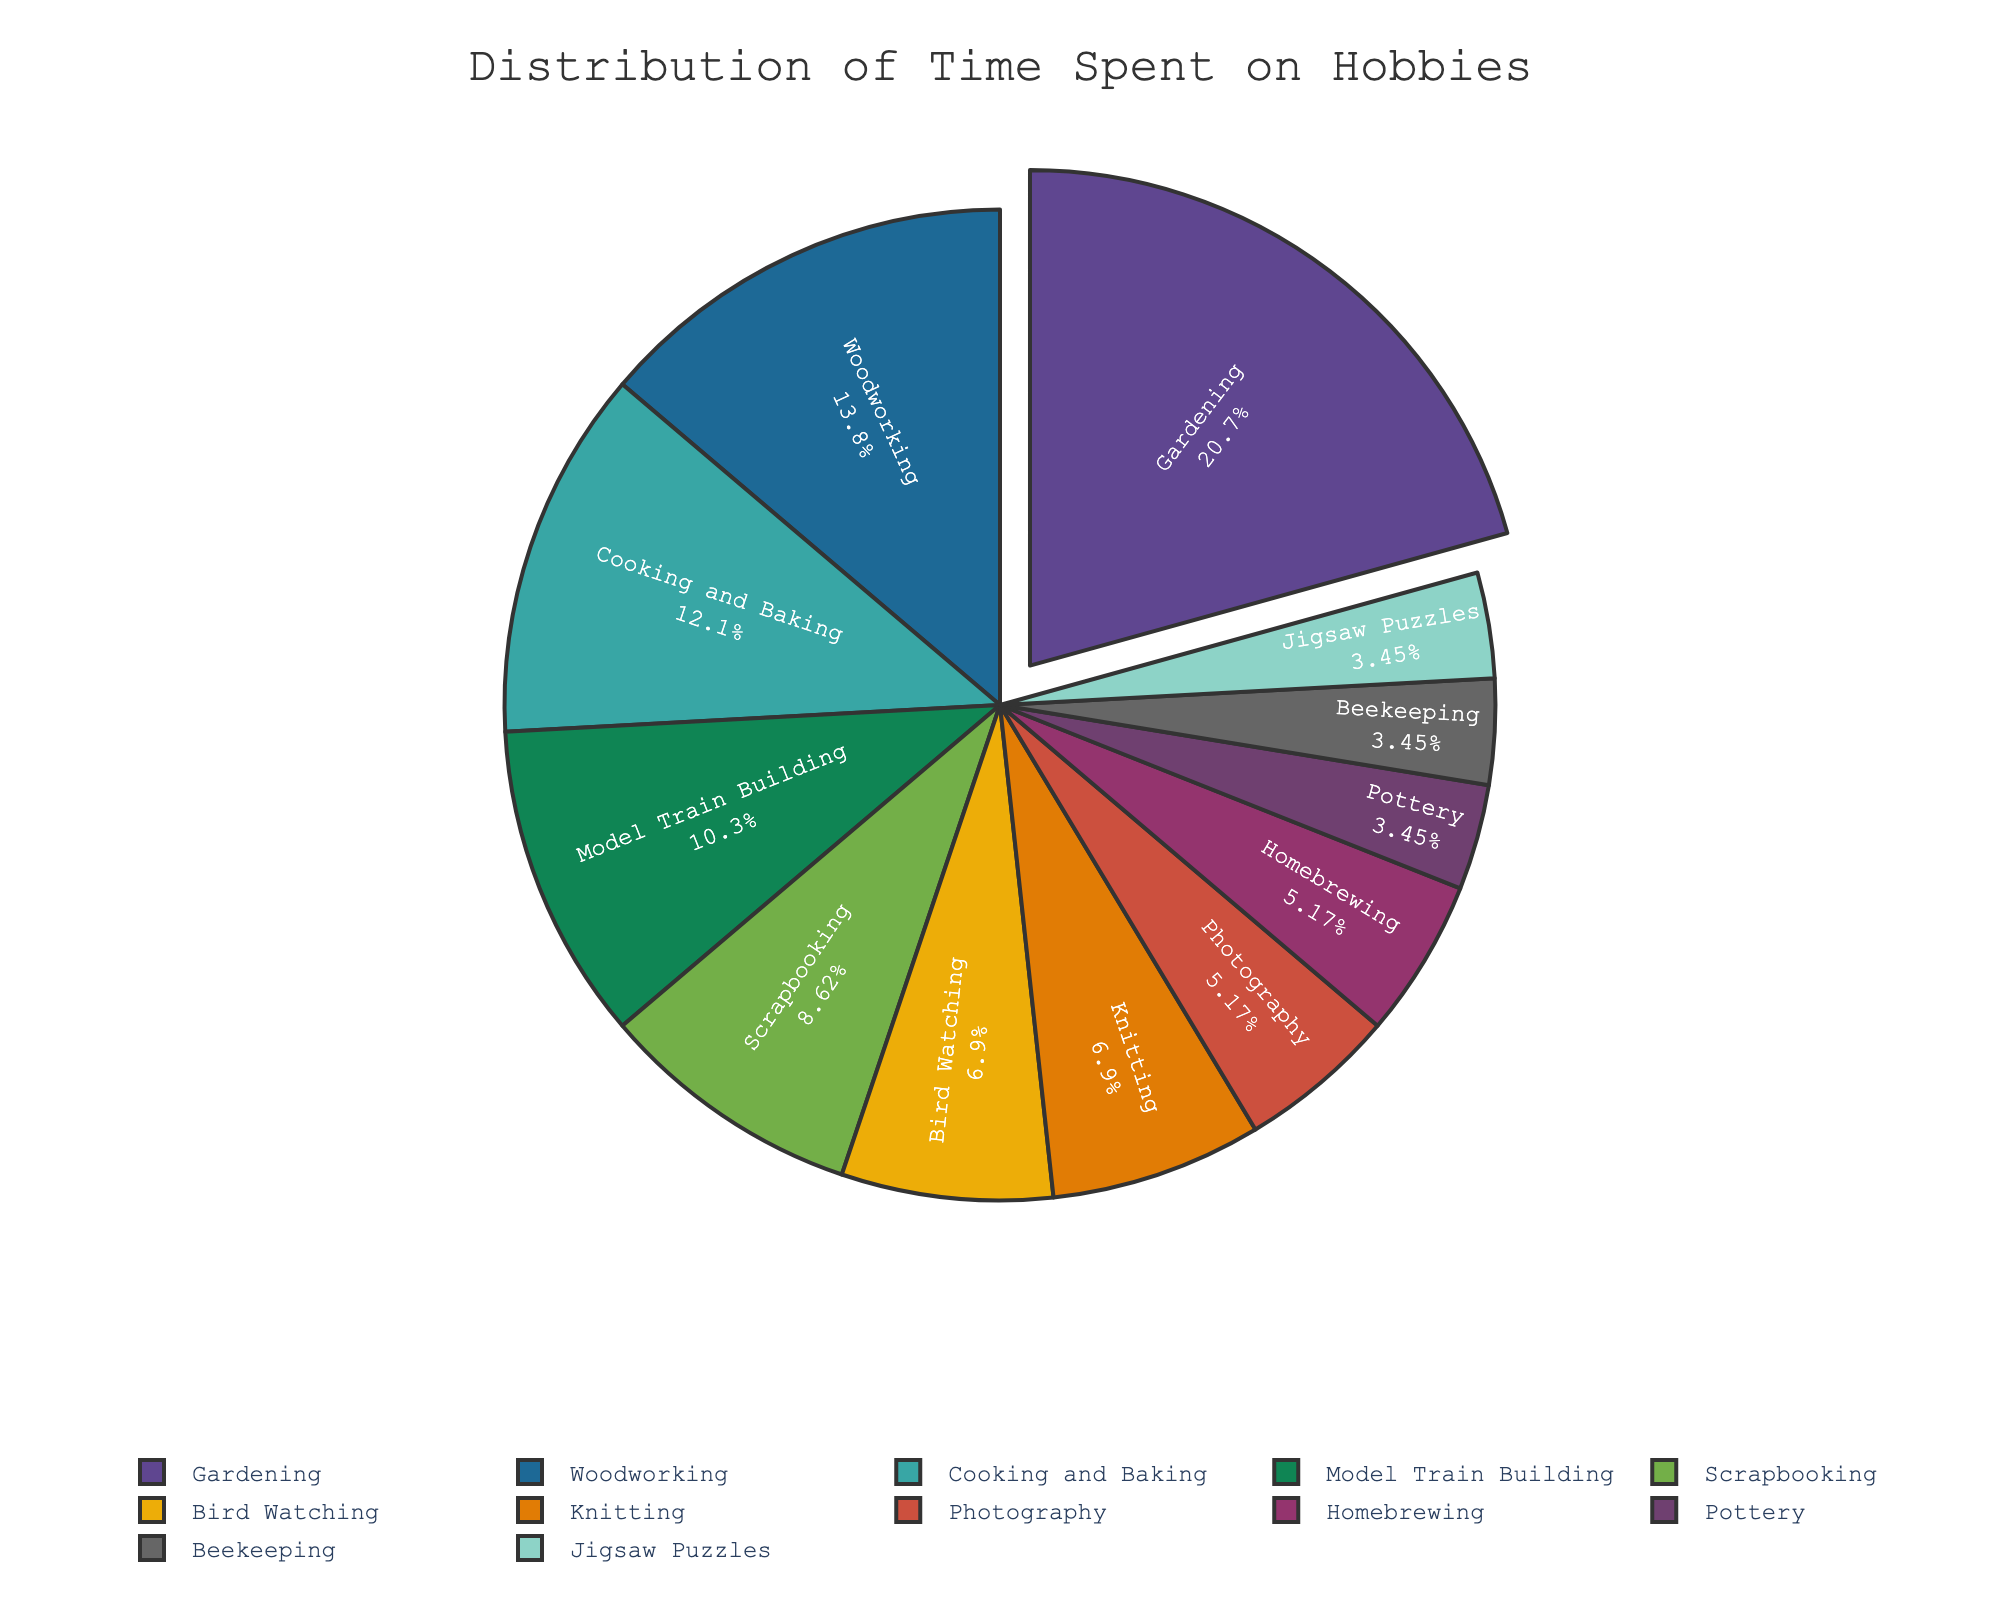what hobby takes up the most time? Gardening is at the largest part of the pie chart.
Answer: Gardening which two hobbies take up the same amount of time? Knitting and Bird Watching each occupy the same size slice of 4 hours per week in the pie chart.
Answer: Knitting and Bird Watching how many hours are spent on the three most popular hobbies combined? Adding the hours for Gardening (12), Woodworking (8), and Cooking and Baking (7) gives 12 + 8 + 7 = 27 hours per week.
Answer: 27 which hobby spends less time, Model Train Building or Homebrewing? Model Train Building has a larger slice (6 hours) compared to Homebrewing (3 hours).
Answer: Homebrewing how much more time is spent on Photography than on Pottery? Photography takes 3 hours, and Pottery takes 2 hours, so 3 - 2 = 1 more hour is spent on Photography.
Answer: 1 hour which hobby has the least amount of time spent? Pottery, Beekeeping, and Jigsaw Puzzles each occupy the smallest slices, with 2 hours per week.
Answer: Pottery, Beekeeping, and Jigsaw Puzzles what percent of the total time is spent on Woodworking? The pie chart suggests time spent on Woodworking is 8 hours. The total time is 12+8+7+6+5+4+4+3+3+2+2+2 = 58 hours. So, (8/58)*100 ≈ 13.79%.
Answer: 13.79% is more time spent on Cooking and Baking or Bird Watching and Knitting combined? Cooking and Baking has 7 hours, Bird Watching and Knitting are 4+4 = 8 hours, so more time is spent on Bird Watching and Knitting combined.
Answer: Bird Watching and Knitting combined which hobby's slice is exactly half of the Gardening slice? Gardening takes 12 hours; half of that is 6 hours, which matches Model Train Building.
Answer: Model Train Building 